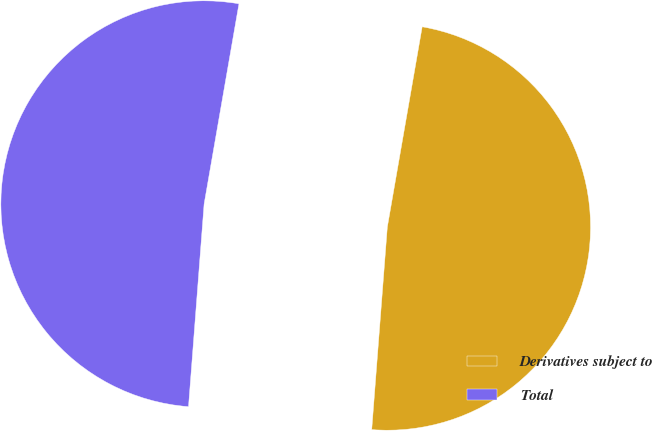<chart> <loc_0><loc_0><loc_500><loc_500><pie_chart><fcel>Derivatives subject to<fcel>Total<nl><fcel>48.48%<fcel>51.52%<nl></chart> 